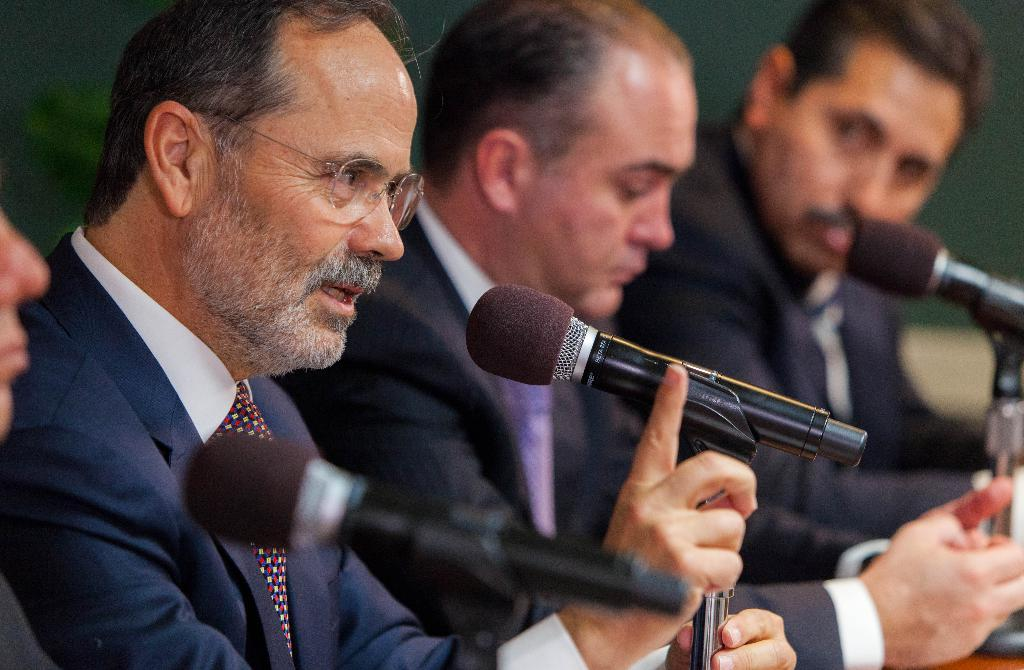What are the people in the image doing? The people in the image are sitting. What type of clothing are the people wearing? The people are wearing ties and coats. Can you describe any specific accessory one of the people is wearing? One person is wearing glasses. What equipment is visible in the image? There are microphones with stands in the image. What color is the background in the image? The background is in dark green. What hobbies do the people in the image have? There is no information about the people's hobbies in the image. What decision are the people in the image making? There is no indication of a decision-making process in the image. 